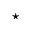Convert formula to latex. <formula><loc_0><loc_0><loc_500><loc_500>^ { * }</formula> 